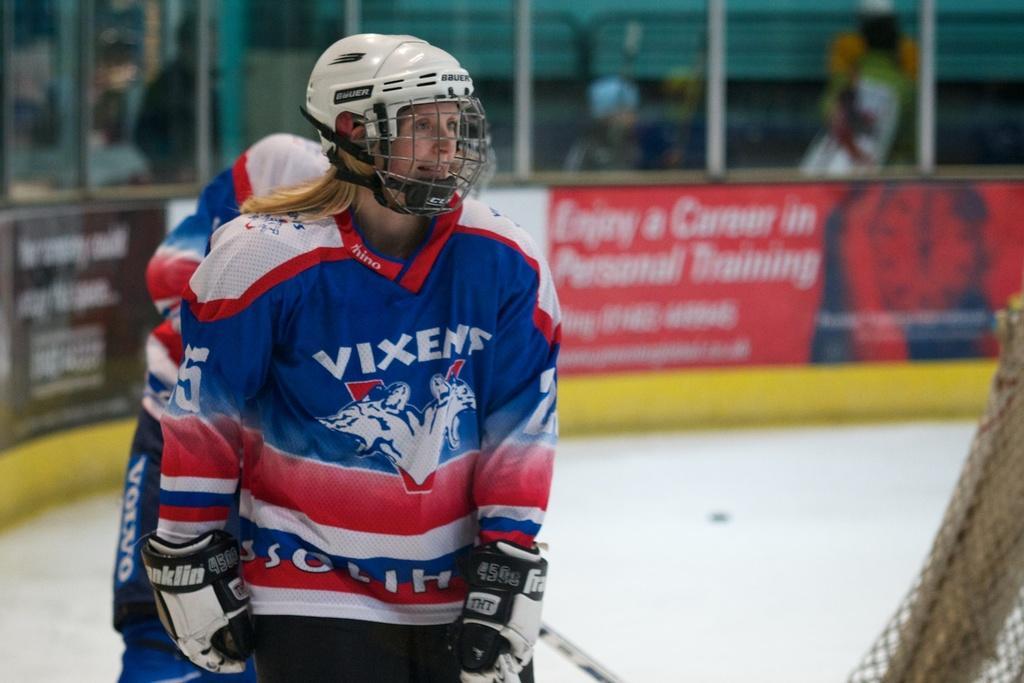In one or two sentences, can you explain what this image depicts? There is a woman wearing white color helmet, smiling and standing. In the background, there is other person, there are hoardings, persons and other objects. 